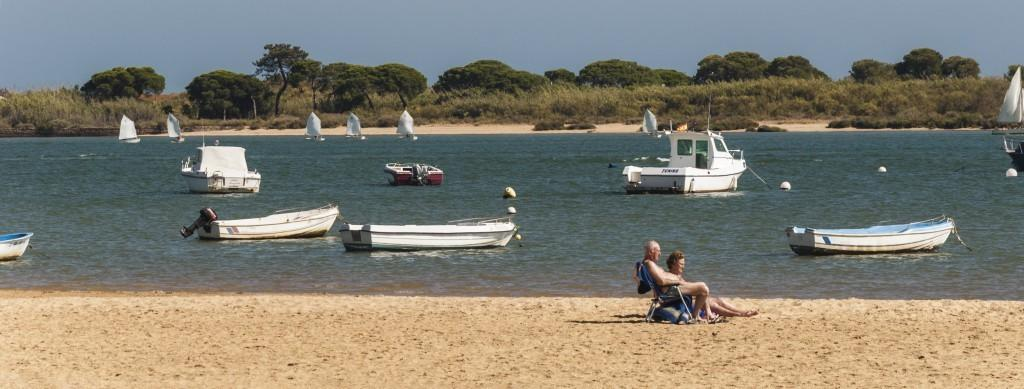What is happening in the water in the image? There are ships sailing in the water. What can be seen in the background of the image? There are trees visible in the image. What are the couple doing in the image? The couple is sitting at the sea shore. Can you see a cave behind the couple in the image? There is no cave visible in the image. Are there any yaks present in the image? There are no yaks present in the image. 